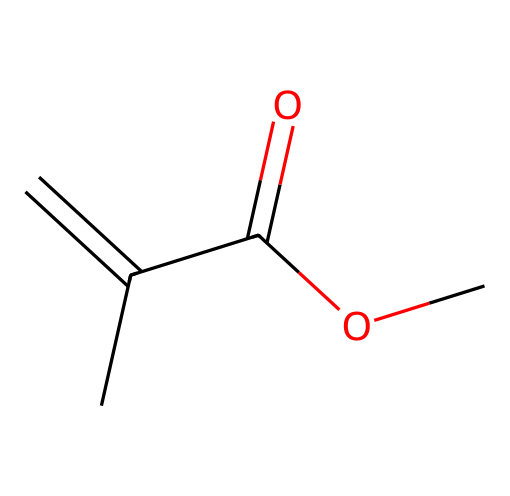What is the total number of carbon atoms in the molecule? The SMILES representation indicates there are four carbon (C) atoms: one in the branch (C(C)) and three in the chain (C=C and C(=O)).
Answer: four How many oxygen atoms are present in the chemical structure? The molecule contains two oxygen (O) atoms; one is connected to the carbonyl (C=O) group and the other is part of the ester (OC).
Answer: two What type of functional group is represented by C(=O)? The carbon atom bonded to oxygen with a double bond (C=O) represents a carbonyl group, commonly found in ketones and aldehydes.
Answer: carbonyl What type of chemical is this based on its structure? The presence of carbon-carbon double bonds and a functional group indicates that this compound is an acrylic monomer.
Answer: acrylic monomer How many double bonds does the molecule have? The structure contains one double bond between the two carbon atoms indicated by "C=C".
Answer: one What is the main use of this type of monomer in children's art supplies? Acrylic monomers are primarily used to produce acrylic paints and adhesives, which provide vibrant colors and flexibility in children's art projects.
Answer: paints and adhesives 